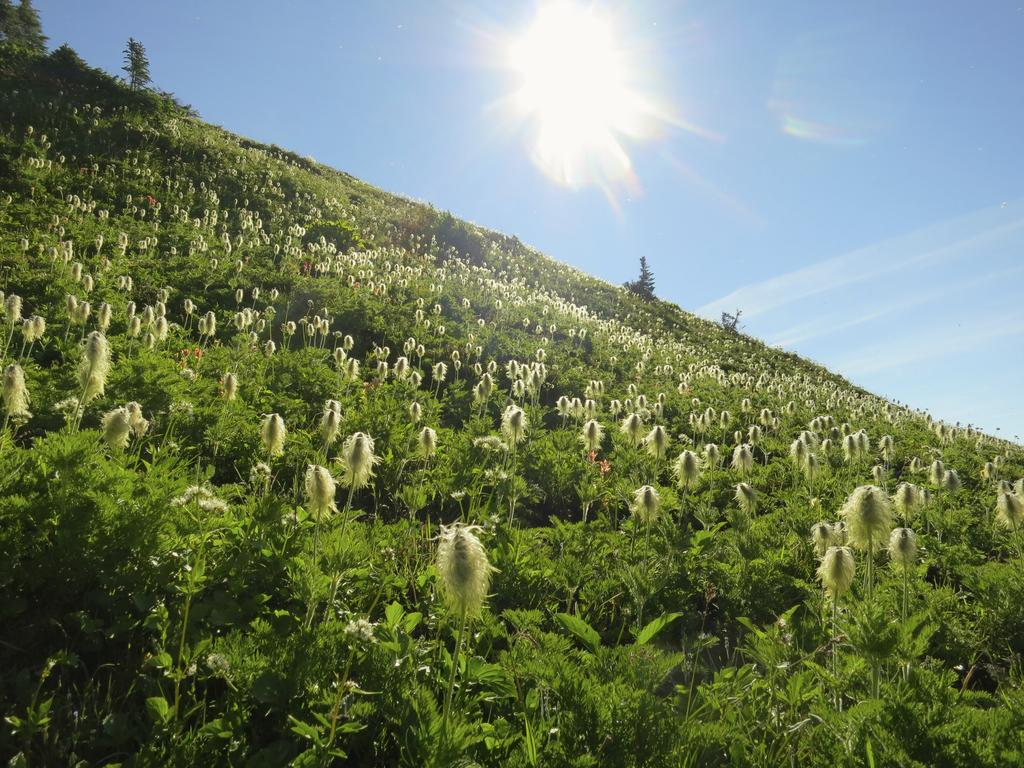What type of vegetation is on the ground in the image? There are plants on the ground in the image. What can be seen in the background of the image? There are trees visible in the background of the image. What is the condition of the sky in the image? The sky is clear in the image. Can the sun be seen in the sky? Yes, the sun is visible in the sky. What grade did the plants receive for their performance in the image? There is no indication of a grading system or performance evaluation for the plants in the image. What authority figure is present in the image to oversee the plants? There is no authority figure present in the image; it is a natural scene with plants and trees. 